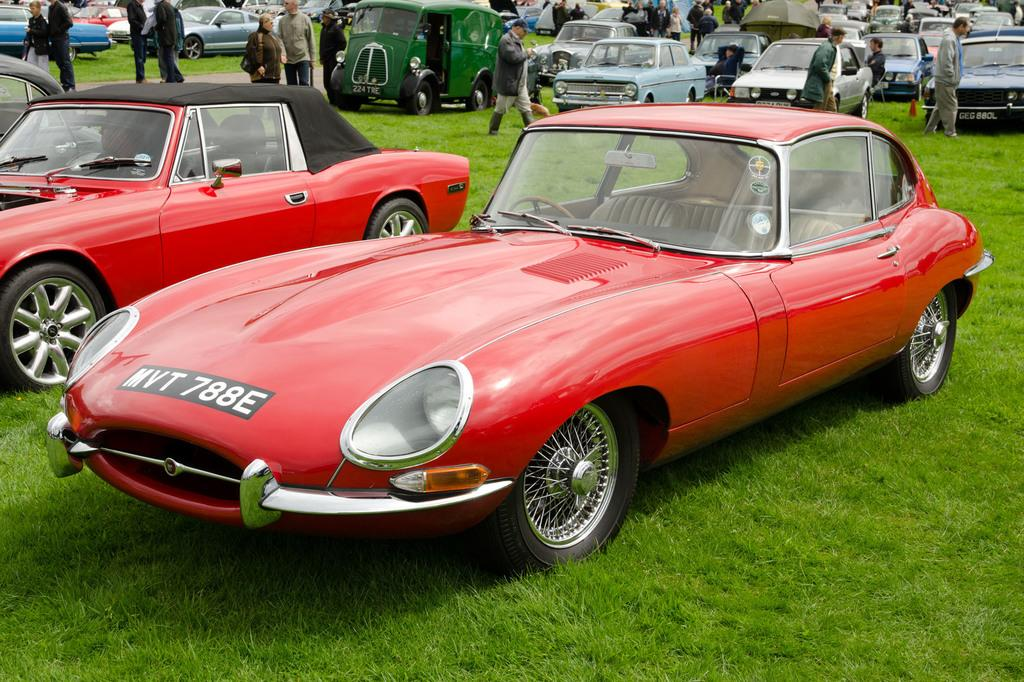What types of objects are on the ground in the image? There are vehicles on the ground in the image. Who or what else can be seen in the image? There are people visible in the image. What type of jewel is being processed in space in the image? There is no reference to a jewel or space in the image; it features vehicles on the ground and people. 